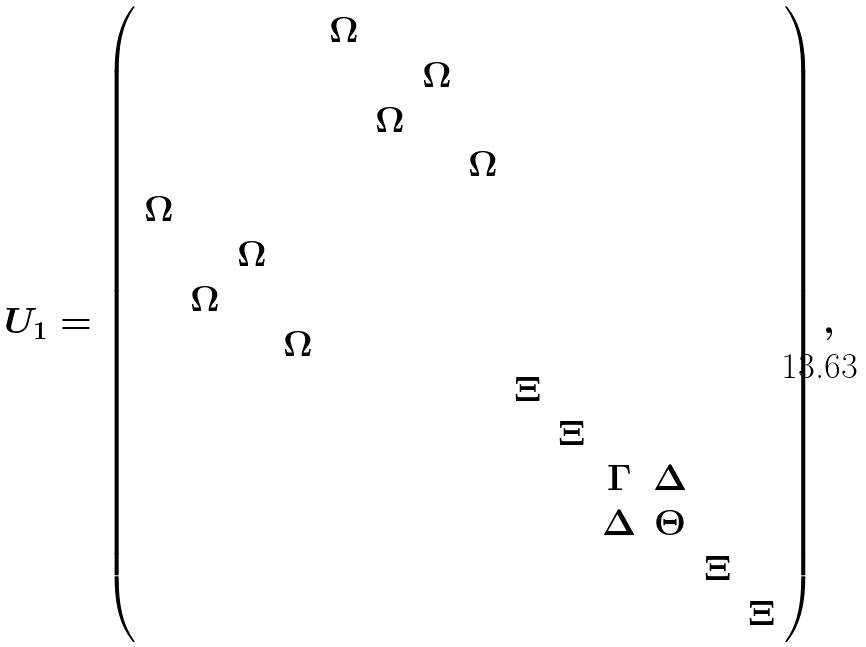<formula> <loc_0><loc_0><loc_500><loc_500>U _ { 1 } = \left ( \begin{array} { c c c c c c c c c c c c c c } & & & & { \Omega } & & & & & & & & & \\ & & & & & & { \Omega } & & & & & & & \\ & & & & & { \Omega } & & & & & & & & \\ & & & & & & & { \Omega } & & & & & & \\ { \Omega } & & & & & & & & & & & & & \\ & & { \Omega } & & & & & & & & & & & \\ & { \Omega } & & & & & & & & & & & & \\ & & & { \Omega } & & & & & & & & & & \\ & & & & & & & & \Xi & & & & & \\ & & & & & & & & & \Xi & & & & \\ & & & & & & & & & & \Gamma & \Delta & & \\ & & & & & & & & & & \Delta & \Theta & & \\ & & & & & & & & & & & & \Xi & \\ & & & & & & & & & & & & & \Xi \end{array} \right ) ,</formula> 